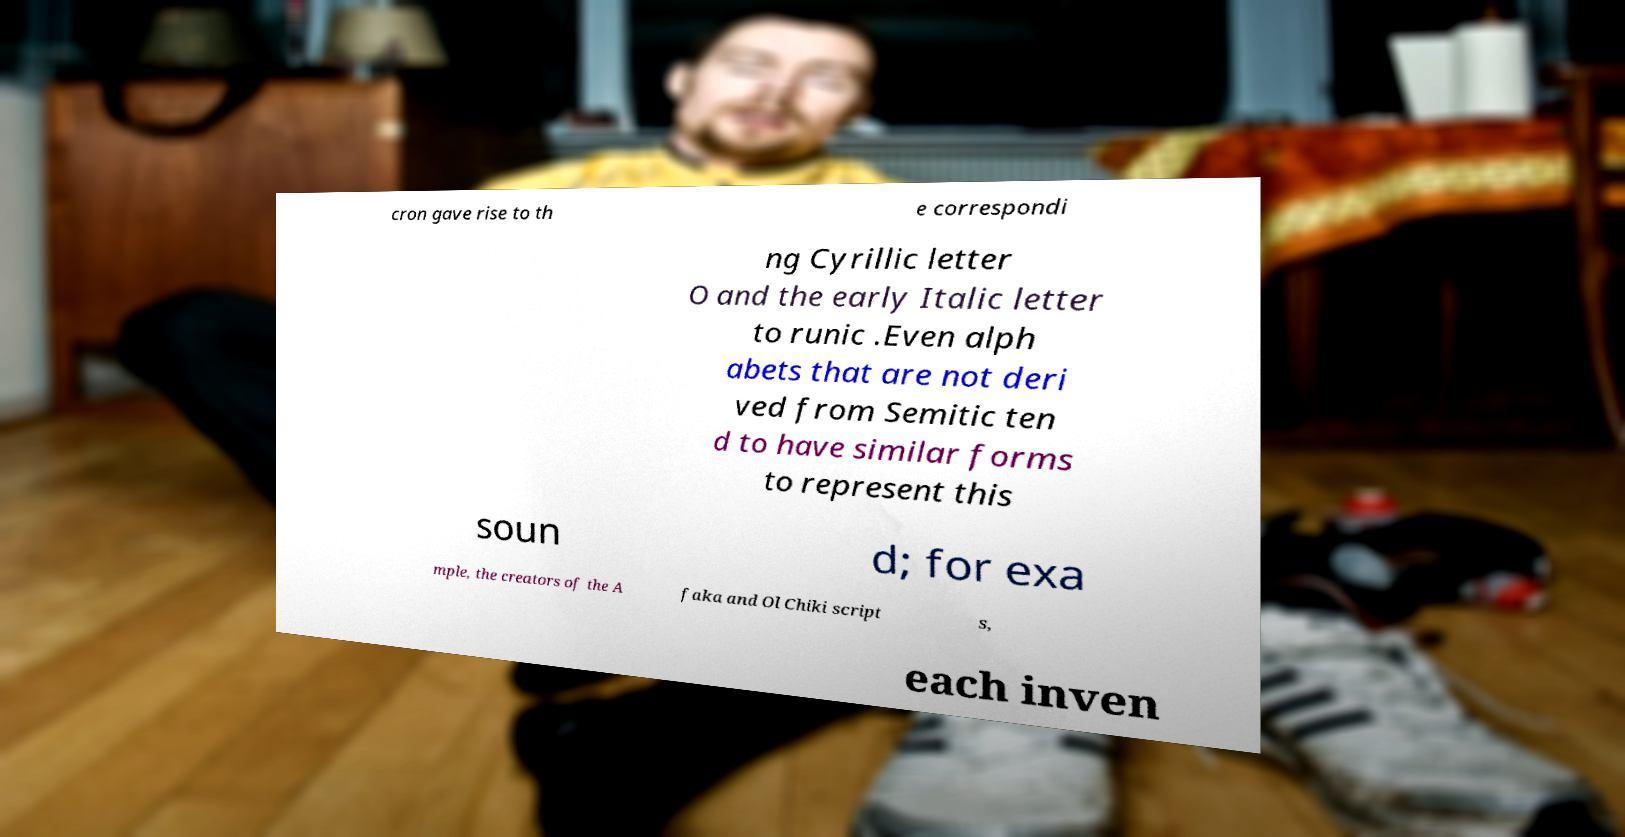Can you accurately transcribe the text from the provided image for me? cron gave rise to th e correspondi ng Cyrillic letter O and the early Italic letter to runic .Even alph abets that are not deri ved from Semitic ten d to have similar forms to represent this soun d; for exa mple, the creators of the A faka and Ol Chiki script s, each inven 